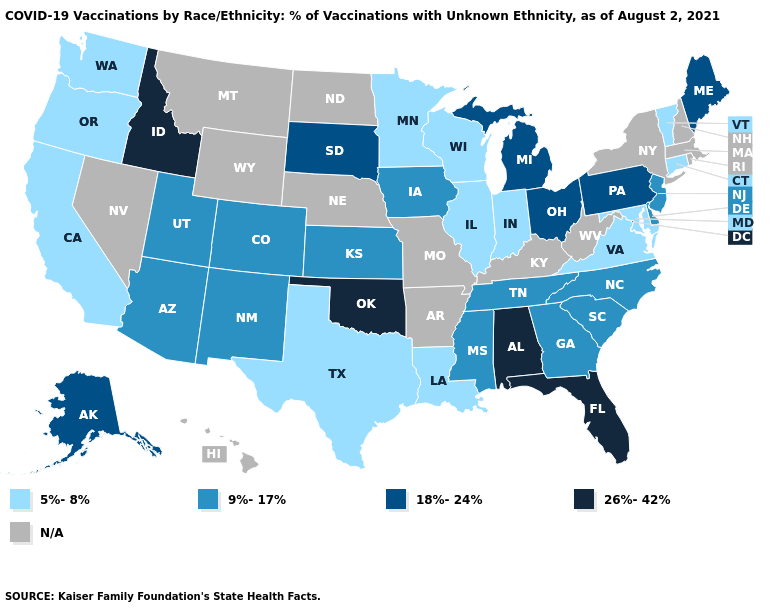Name the states that have a value in the range 9%-17%?
Give a very brief answer. Arizona, Colorado, Delaware, Georgia, Iowa, Kansas, Mississippi, New Jersey, New Mexico, North Carolina, South Carolina, Tennessee, Utah. Which states hav the highest value in the MidWest?
Be succinct. Michigan, Ohio, South Dakota. Name the states that have a value in the range 18%-24%?
Short answer required. Alaska, Maine, Michigan, Ohio, Pennsylvania, South Dakota. What is the value of Massachusetts?
Write a very short answer. N/A. Which states have the lowest value in the USA?
Keep it brief. California, Connecticut, Illinois, Indiana, Louisiana, Maryland, Minnesota, Oregon, Texas, Vermont, Virginia, Washington, Wisconsin. How many symbols are there in the legend?
Quick response, please. 5. What is the highest value in the South ?
Quick response, please. 26%-42%. Is the legend a continuous bar?
Give a very brief answer. No. What is the lowest value in the USA?
Concise answer only. 5%-8%. What is the value of Indiana?
Keep it brief. 5%-8%. What is the value of California?
Short answer required. 5%-8%. Name the states that have a value in the range 18%-24%?
Give a very brief answer. Alaska, Maine, Michigan, Ohio, Pennsylvania, South Dakota. What is the value of Minnesota?
Keep it brief. 5%-8%. Does Vermont have the highest value in the Northeast?
Write a very short answer. No. Among the states that border Oklahoma , which have the lowest value?
Answer briefly. Texas. 